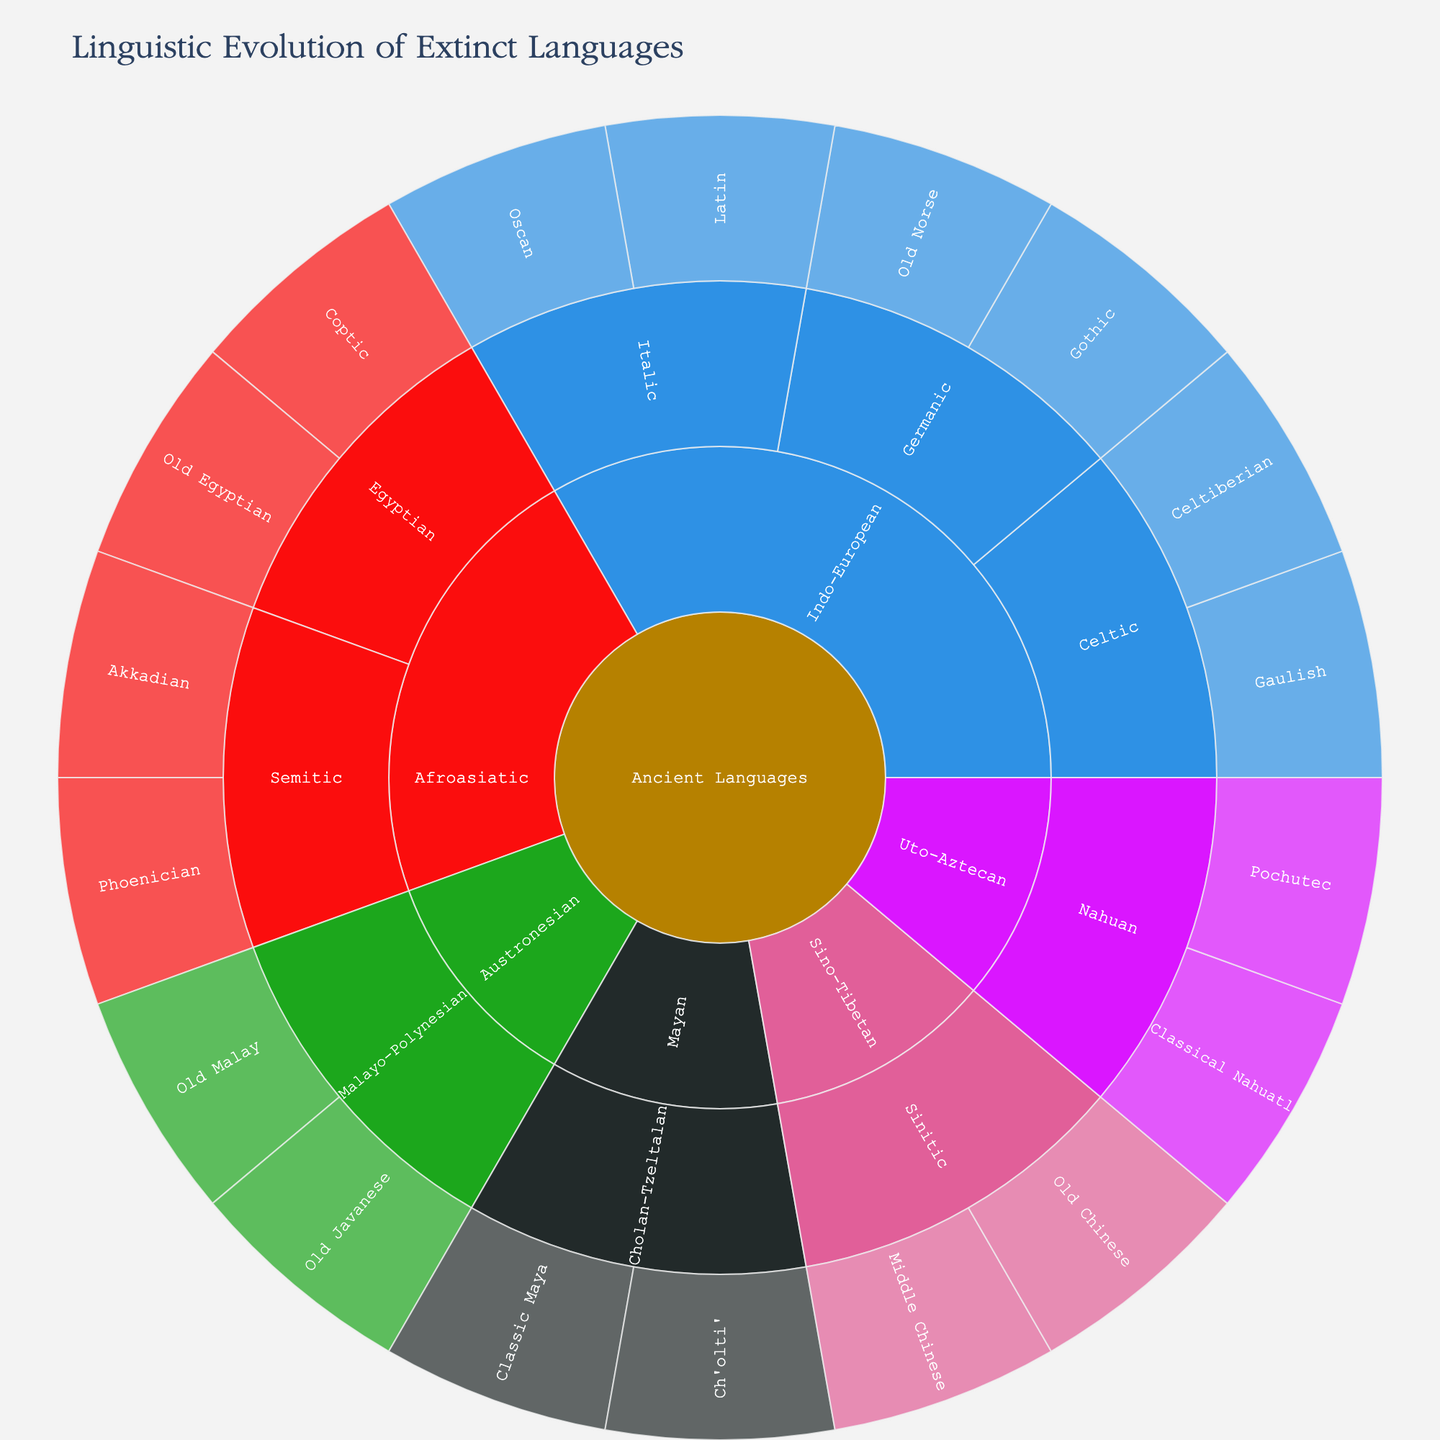What is the title of the figure? The title is prominently displayed at the top of the figure. It provides a summary of the visualized data. The title is "Linguistic Evolution of Extinct Languages"
Answer: Linguistic Evolution of Extinct Languages How many language families are depicted in the figure? By counting the number of primary branches emanating from the central "Ancient Languages" node, we can determine the number of language families. There are five branches: Indo-European, Afroasiatic, Sino-Tibetan, Austronesian, and Uto-Aztecan/Mayan
Answer: Five Which language family has the most sub-branches? To find the language family with the most sub-branches, count the sub-branches for each primary branch. Indo-European has three sub-branches (Germanic, Italic, Celtic), while other families have fewer sub-branches
Answer: Indo-European What are the two sub-branches of the Germanic branch? Locate the Germanic branch under Indo-European and identify its two sub-branches. The two sub-branches are Old Norse and Gothic
Answer: Old Norse and Gothic Which language family includes Old Egyptian and Coptic? Identify the sub-branches that contain Old Egyptian and Coptic, and trace them back to the primary branch. They belong to the Afroasiatic family, specifically under the Egyptian sub-branch
Answer: Afroasiatic Which language has more sub-branches: Germanic or Italic? Compare the number of sub-branches under the Germanic and Italic branches of the Indo-European family. Germanic has 2 sub-branches (Old Norse, Gothic), while Italic also has 2 sub-branches (Latin, Oscan)
Answer: They are equal How many extinct languages are depicted under the Austronesian family? Count the number of leaf nodes under the Austronesian family. Austronesian has 2 extinct languages: Old Javanese and Old Malay
Answer: Two What is the relationship between Classical Nahuatl and Pochutec? Examine the sub-branch level of the Uto-Aztecan family to determine the relationship. Classical Nahuatl and Pochutec are both under the Nahuan sub-branch
Answer: Both are part of Nahuan How many sub-branches are present under the Semitic branch? Identify the Semitic branch under the Afroasiatic family and count the number of sub-branches. There are two sub-branches: Akkadian and Phoenician
Answer: Two Out of the listed languages, which one is part of the Sino-Tibetan family but not Sino-Tibetan, Sinitic? The Sino-Tibetan family branches into "Sinitic," which includes Old Chinese and Middle Chinese. No other listed languages are part of Sino-Tibetan but not Sinitic, so all Sino-Tibetan languages listed come under the Sinitic sub-branch
Answer: None 